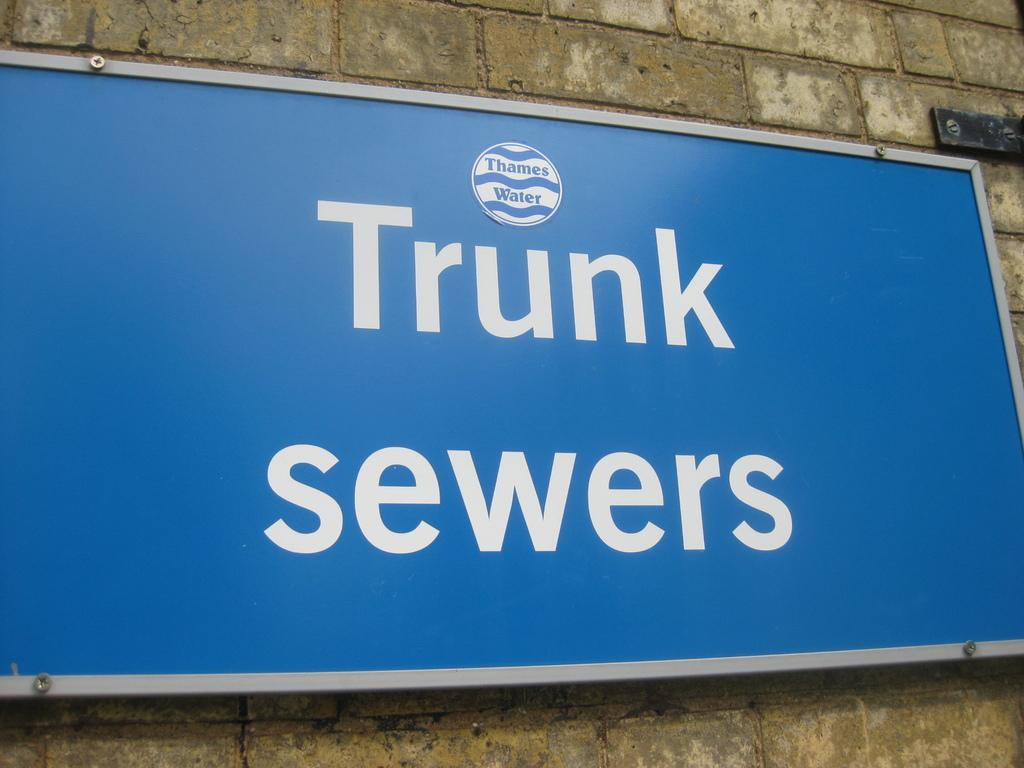<image>
Offer a succinct explanation of the picture presented. a sign on the wall that says 'trunk sewers' on it 